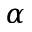Convert formula to latex. <formula><loc_0><loc_0><loc_500><loc_500>\alpha</formula> 